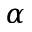Convert formula to latex. <formula><loc_0><loc_0><loc_500><loc_500>\alpha</formula> 